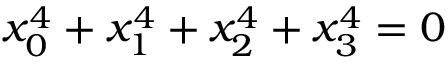<formula> <loc_0><loc_0><loc_500><loc_500>x _ { 0 } ^ { 4 } + x _ { 1 } ^ { 4 } + x _ { 2 } ^ { 4 } + x _ { 3 } ^ { 4 } = 0</formula> 